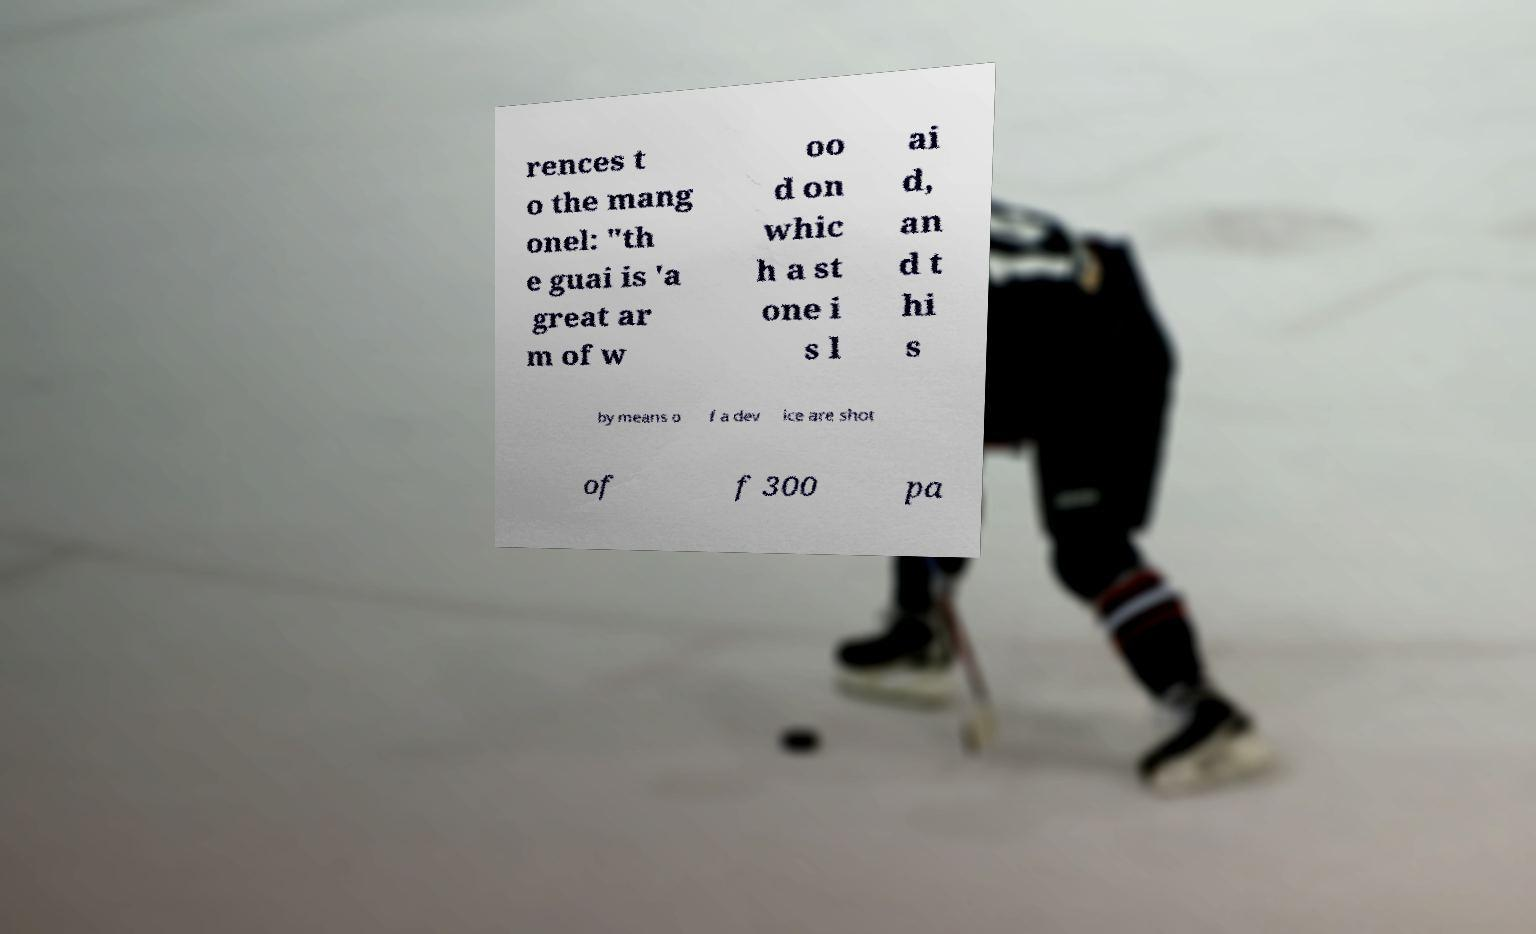Please read and relay the text visible in this image. What does it say? rences t o the mang onel: "th e guai is 'a great ar m of w oo d on whic h a st one i s l ai d, an d t hi s by means o f a dev ice are shot of f 300 pa 